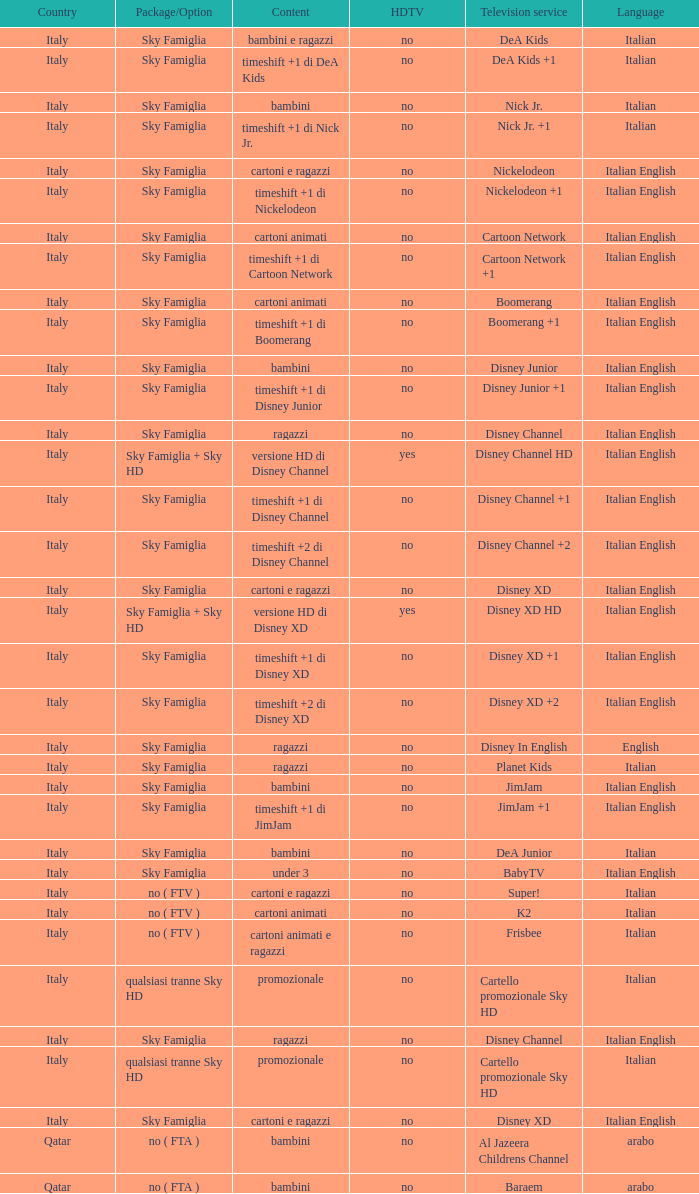What shows as Content for the Television service of nickelodeon +1? Timeshift +1 di nickelodeon. 